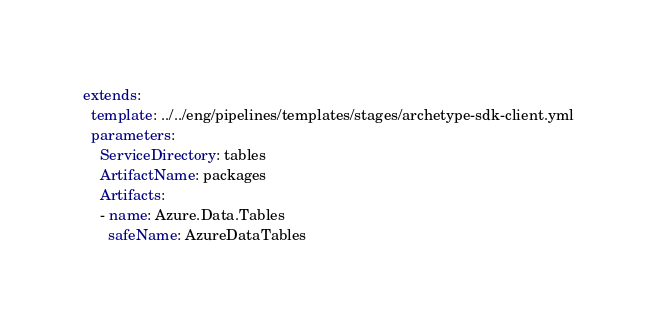Convert code to text. <code><loc_0><loc_0><loc_500><loc_500><_YAML_>

extends:
  template: ../../eng/pipelines/templates/stages/archetype-sdk-client.yml
  parameters:
    ServiceDirectory: tables
    ArtifactName: packages
    Artifacts:
    - name: Azure.Data.Tables
      safeName: AzureDataTables
</code> 